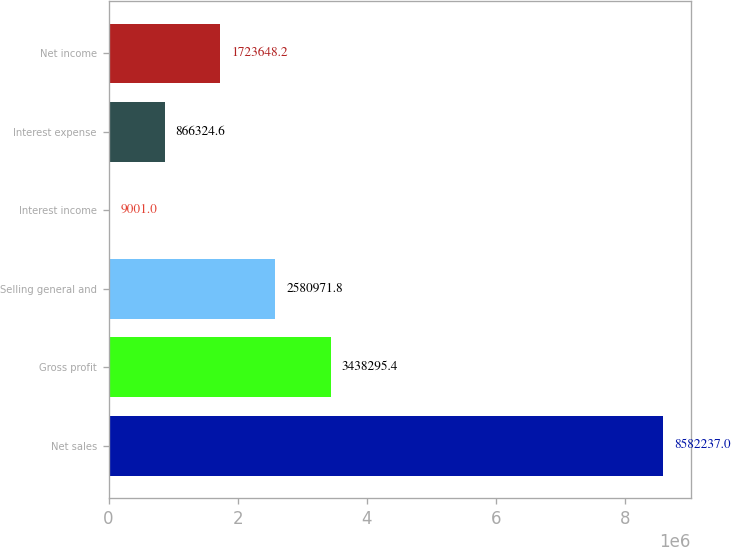<chart> <loc_0><loc_0><loc_500><loc_500><bar_chart><fcel>Net sales<fcel>Gross profit<fcel>Selling general and<fcel>Interest income<fcel>Interest expense<fcel>Net income<nl><fcel>8.58224e+06<fcel>3.4383e+06<fcel>2.58097e+06<fcel>9001<fcel>866325<fcel>1.72365e+06<nl></chart> 